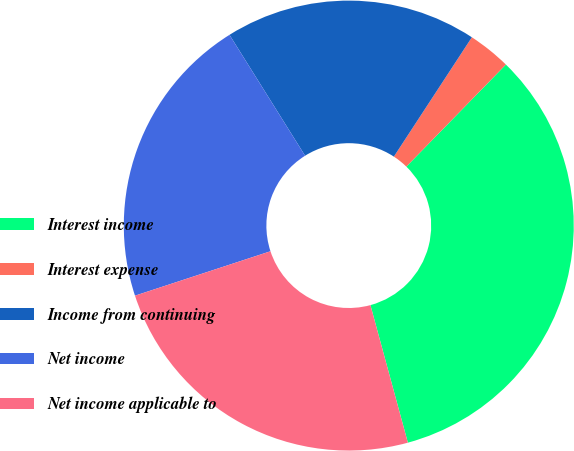Convert chart to OTSL. <chart><loc_0><loc_0><loc_500><loc_500><pie_chart><fcel>Interest income<fcel>Interest expense<fcel>Income from continuing<fcel>Net income<fcel>Net income applicable to<nl><fcel>33.47%<fcel>3.09%<fcel>18.11%<fcel>21.15%<fcel>24.19%<nl></chart> 